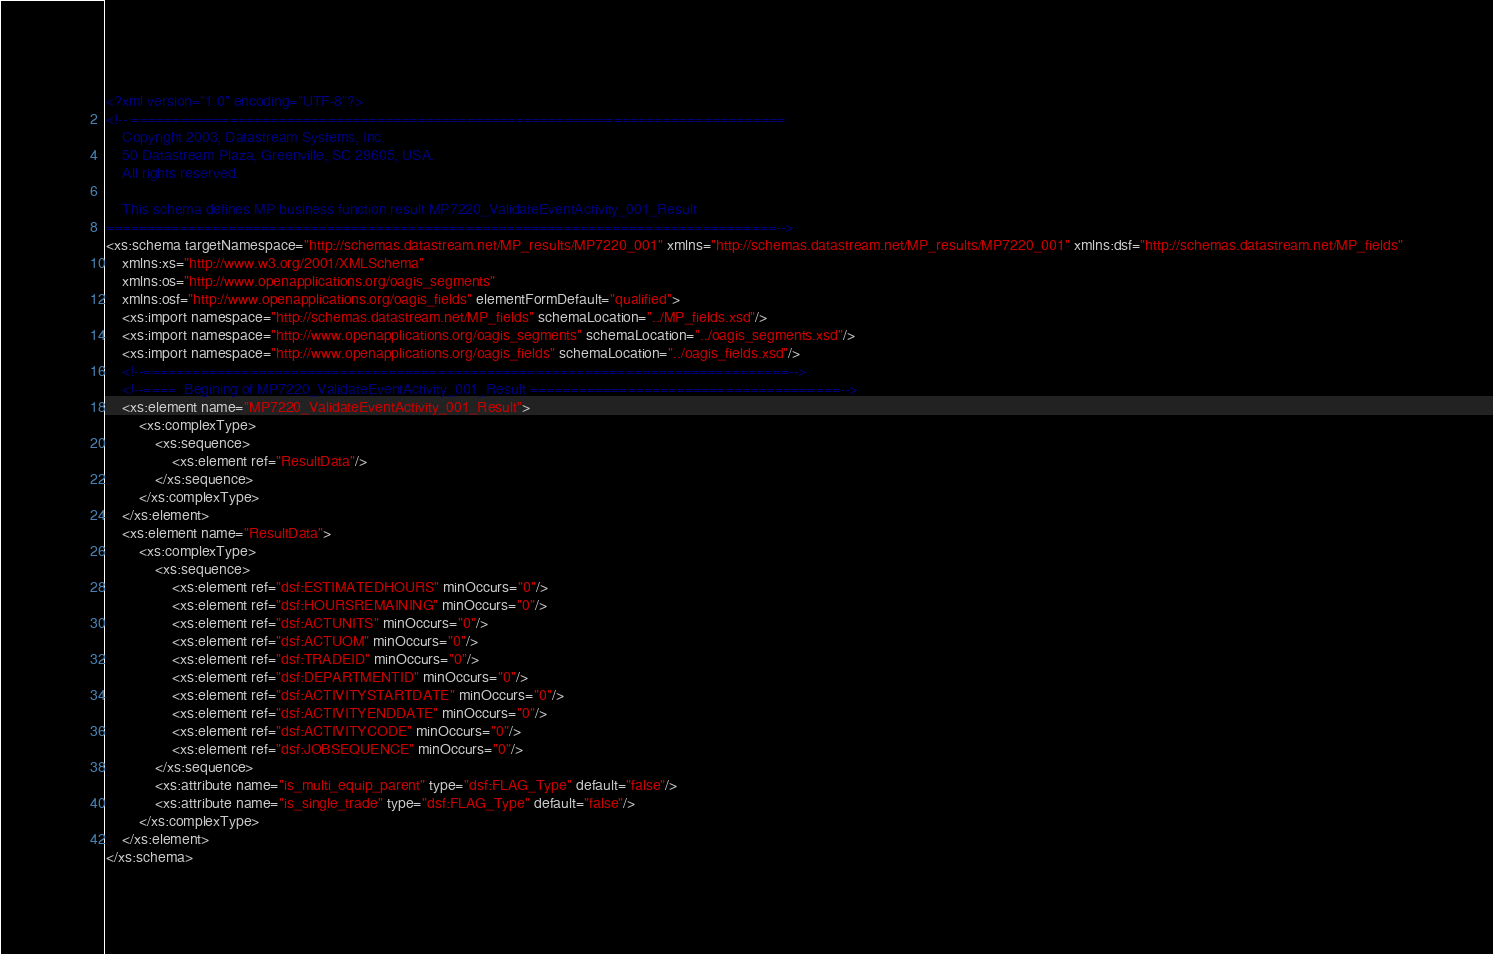<code> <loc_0><loc_0><loc_500><loc_500><_XML_><?xml version="1.0" encoding="UTF-8"?>
<!-- ================================================================================
	Copyright 2003, Datastream Systems, Inc.
	50 Datastream Plaza, Greenville, SC 29605, USA.
	All rights reserved.

    This schema defines MP business function result MP7220_ValidateEventActivity_001_Result
==================================================================================-->
<xs:schema targetNamespace="http://schemas.datastream.net/MP_results/MP7220_001" xmlns="http://schemas.datastream.net/MP_results/MP7220_001" xmlns:dsf="http://schemas.datastream.net/MP_fields"
	xmlns:xs="http://www.w3.org/2001/XMLSchema"
	xmlns:os="http://www.openapplications.org/oagis_segments"
	xmlns:osf="http://www.openapplications.org/oagis_fields" elementFormDefault="qualified">
	<xs:import namespace="http://schemas.datastream.net/MP_fields" schemaLocation="../MP_fields.xsd"/>
	<xs:import namespace="http://www.openapplications.org/oagis_segments" schemaLocation="../oagis_segments.xsd"/>
	<xs:import namespace="http://www.openapplications.org/oagis_fields" schemaLocation="../oagis_fields.xsd"/>
	<!--===============================================================================-->
	<!--====  Begining of MP7220_ValidateEventActivity_001_Result ======================================-->
	<xs:element name="MP7220_ValidateEventActivity_001_Result">
		<xs:complexType>
			<xs:sequence>
				<xs:element ref="ResultData"/>
			</xs:sequence>
		</xs:complexType>
	</xs:element>
	<xs:element name="ResultData">
		<xs:complexType>
			<xs:sequence>
				<xs:element ref="dsf:ESTIMATEDHOURS" minOccurs="0"/>
				<xs:element ref="dsf:HOURSREMAINING" minOccurs="0"/>
				<xs:element ref="dsf:ACTUNITS" minOccurs="0"/>
				<xs:element ref="dsf:ACTUOM" minOccurs="0"/>
				<xs:element ref="dsf:TRADEID" minOccurs="0"/>
				<xs:element ref="dsf:DEPARTMENTID" minOccurs="0"/>
				<xs:element ref="dsf:ACTIVITYSTARTDATE" minOccurs="0"/>
				<xs:element ref="dsf:ACTIVITYENDDATE" minOccurs="0"/>
				<xs:element ref="dsf:ACTIVITYCODE" minOccurs="0"/>
				<xs:element ref="dsf:JOBSEQUENCE" minOccurs="0"/>
			</xs:sequence>
			<xs:attribute name="is_multi_equip_parent" type="dsf:FLAG_Type" default="false"/>
			<xs:attribute name="is_single_trade" type="dsf:FLAG_Type" default="false"/>
		</xs:complexType>
	</xs:element>
</xs:schema>
</code> 